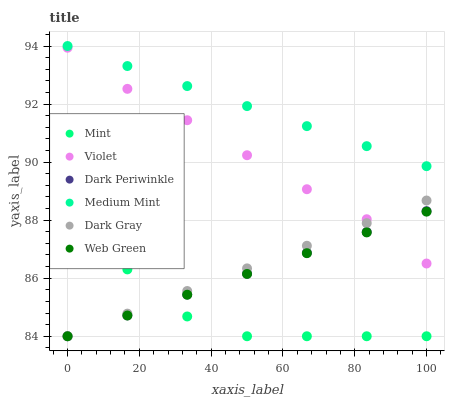Does Mint have the minimum area under the curve?
Answer yes or no. Yes. Does Medium Mint have the maximum area under the curve?
Answer yes or no. Yes. Does Web Green have the minimum area under the curve?
Answer yes or no. No. Does Web Green have the maximum area under the curve?
Answer yes or no. No. Is Medium Mint the smoothest?
Answer yes or no. Yes. Is Mint the roughest?
Answer yes or no. Yes. Is Web Green the smoothest?
Answer yes or no. No. Is Web Green the roughest?
Answer yes or no. No. Does Web Green have the lowest value?
Answer yes or no. Yes. Does Violet have the lowest value?
Answer yes or no. No. Does Medium Mint have the highest value?
Answer yes or no. Yes. Does Web Green have the highest value?
Answer yes or no. No. Is Web Green less than Medium Mint?
Answer yes or no. Yes. Is Medium Mint greater than Dark Gray?
Answer yes or no. Yes. Does Dark Periwinkle intersect Dark Gray?
Answer yes or no. Yes. Is Dark Periwinkle less than Dark Gray?
Answer yes or no. No. Is Dark Periwinkle greater than Dark Gray?
Answer yes or no. No. Does Web Green intersect Medium Mint?
Answer yes or no. No. 